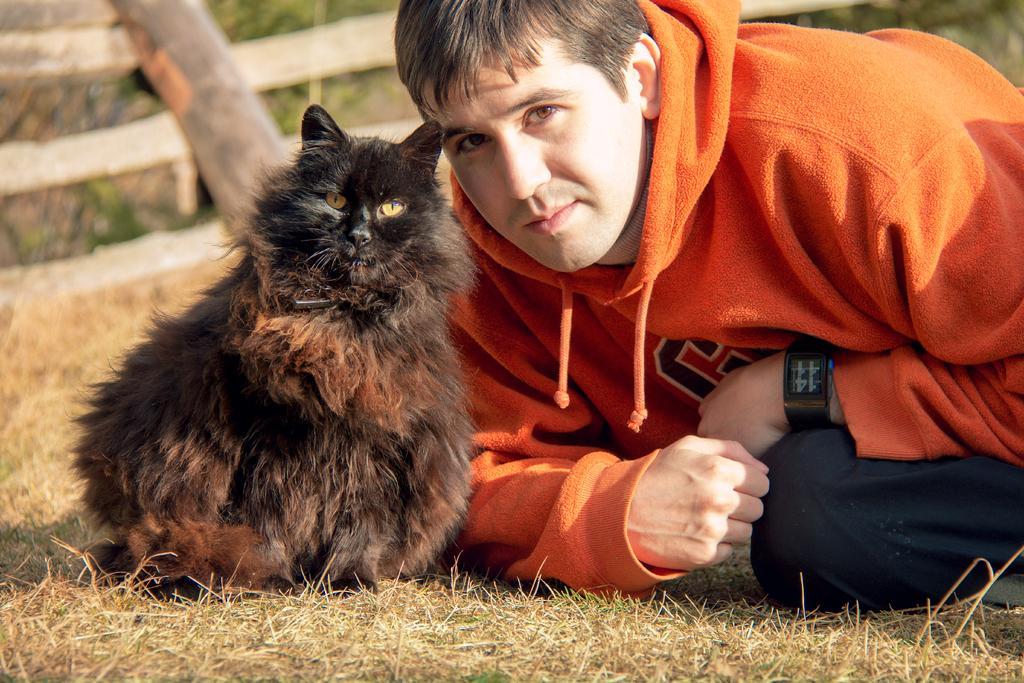Could you give a brief overview of what you see in this image? In this picture we can see a ground which is covered with a dry grass and on the right side there is a Person sitting on the ground wearing a Hoodie and a Watch and on the left side there is a Cat sitting on the ground and in the background we can see a wooden plank. 